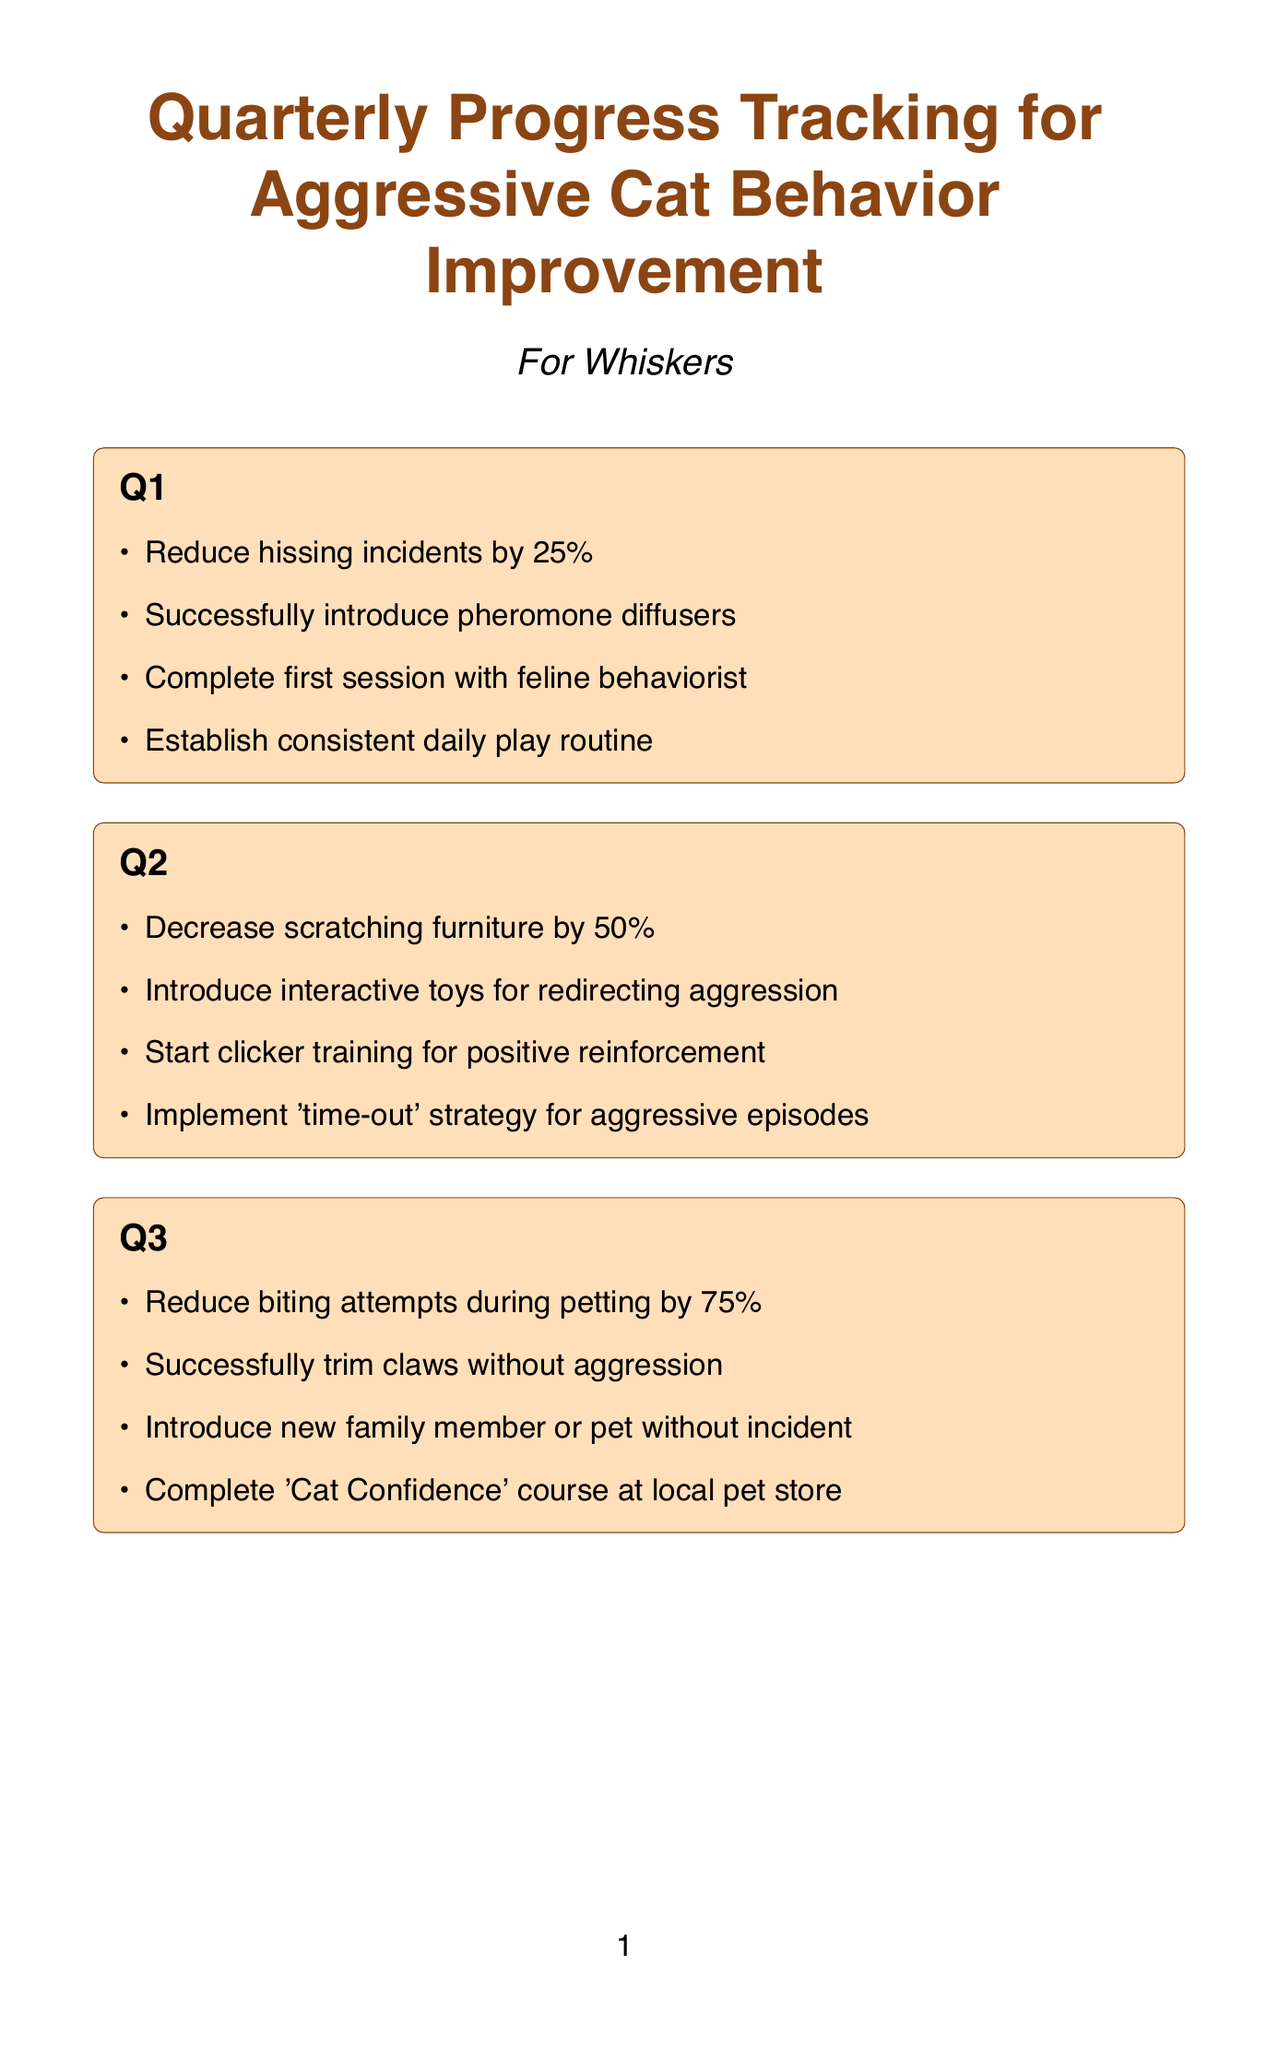What is the cat's name? The cat's name is mentioned at the beginning of the document, which is Whiskers.
Answer: Whiskers What percentage reduction in biting attempts is aimed for in Q3? The document specifies that the goal is to reduce biting attempts during petting by 75% in Q3.
Answer: 75% What is one resource listed for helping with aggressive cat behavior? The document includes multiple resources, one of which is Dr. Emily Johnson - Feline Behaviorist.
Answer: Dr. Emily Johnson - Feline Behaviorist How often are weight checks scheduled? The document indicates that monthly weight checks are planned as part of health checkpoints.
Answer: Monthly What is one environmental change recommended in the document? The document suggests creating more vertical spaces like cat trees and shelves.
Answer: Create more vertical spaces What is the focus of Q2's milestones? The focus of Q2's milestones is on reducing scratching and introducing training and toys for aggression.
Answer: Reduce scratching and introduce training What is a dietary consideration mentioned in the document? One of the dietary considerations is to consult with a vet about potential food allergies.
Answer: Consult with vet about potential food allergies What is one of the tracking metrics? The document lists daily aggression incidents as one of the metrics to track behavior improvement.
Answer: Daily aggression incidents 